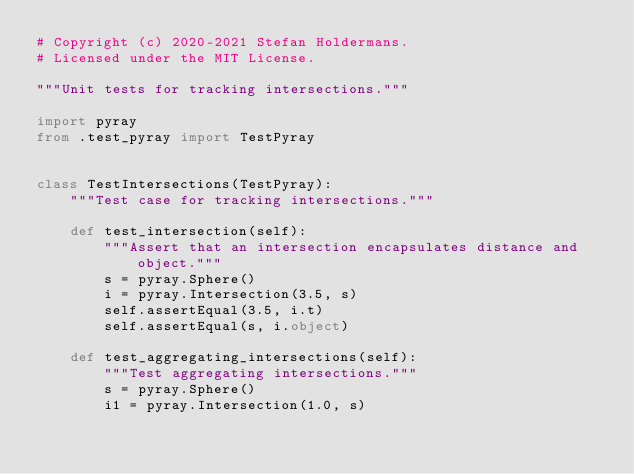<code> <loc_0><loc_0><loc_500><loc_500><_Python_># Copyright (c) 2020-2021 Stefan Holdermans.
# Licensed under the MIT License.

"""Unit tests for tracking intersections."""

import pyray
from .test_pyray import TestPyray


class TestIntersections(TestPyray):
    """Test case for tracking intersections."""

    def test_intersection(self):
        """Assert that an intersection encapsulates distance and object."""
        s = pyray.Sphere()
        i = pyray.Intersection(3.5, s)
        self.assertEqual(3.5, i.t)
        self.assertEqual(s, i.object)

    def test_aggregating_intersections(self):
        """Test aggregating intersections."""
        s = pyray.Sphere()
        i1 = pyray.Intersection(1.0, s)</code> 